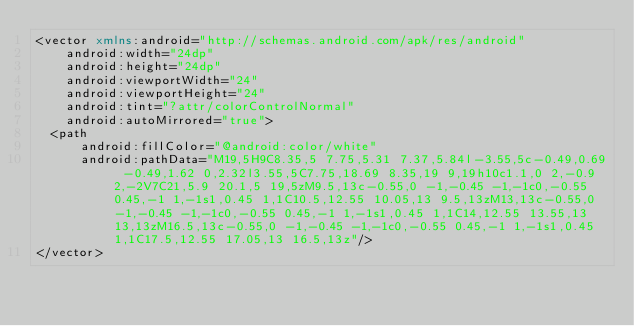<code> <loc_0><loc_0><loc_500><loc_500><_XML_><vector xmlns:android="http://schemas.android.com/apk/res/android"
    android:width="24dp"
    android:height="24dp"
    android:viewportWidth="24"
    android:viewportHeight="24"
    android:tint="?attr/colorControlNormal"
    android:autoMirrored="true">
  <path
      android:fillColor="@android:color/white"
      android:pathData="M19,5H9C8.35,5 7.75,5.31 7.37,5.84l-3.55,5c-0.49,0.69 -0.49,1.62 0,2.32l3.55,5C7.75,18.69 8.35,19 9,19h10c1.1,0 2,-0.9 2,-2V7C21,5.9 20.1,5 19,5zM9.5,13c-0.55,0 -1,-0.45 -1,-1c0,-0.55 0.45,-1 1,-1s1,0.45 1,1C10.5,12.55 10.05,13 9.5,13zM13,13c-0.55,0 -1,-0.45 -1,-1c0,-0.55 0.45,-1 1,-1s1,0.45 1,1C14,12.55 13.55,13 13,13zM16.5,13c-0.55,0 -1,-0.45 -1,-1c0,-0.55 0.45,-1 1,-1s1,0.45 1,1C17.5,12.55 17.05,13 16.5,13z"/>
</vector>
</code> 